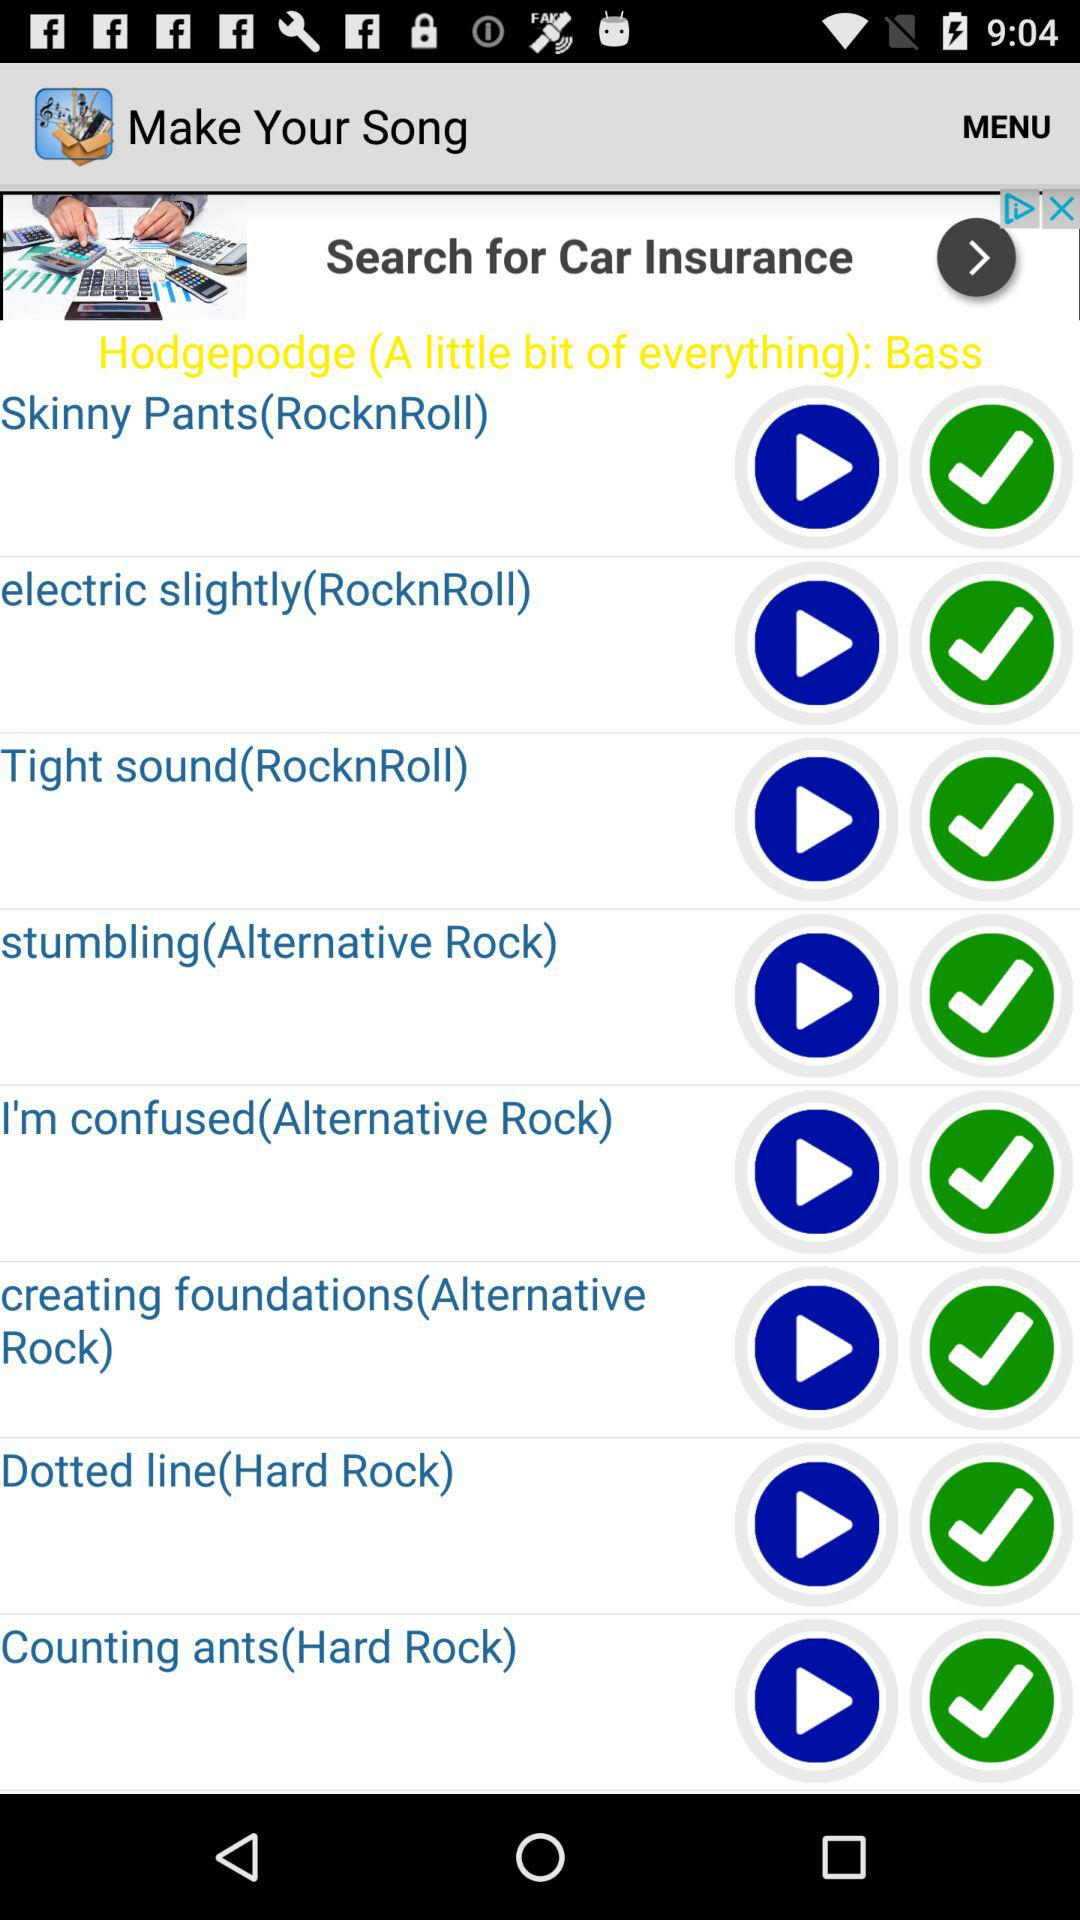What is the name of the application? The name of the application is "Make Your Song". 